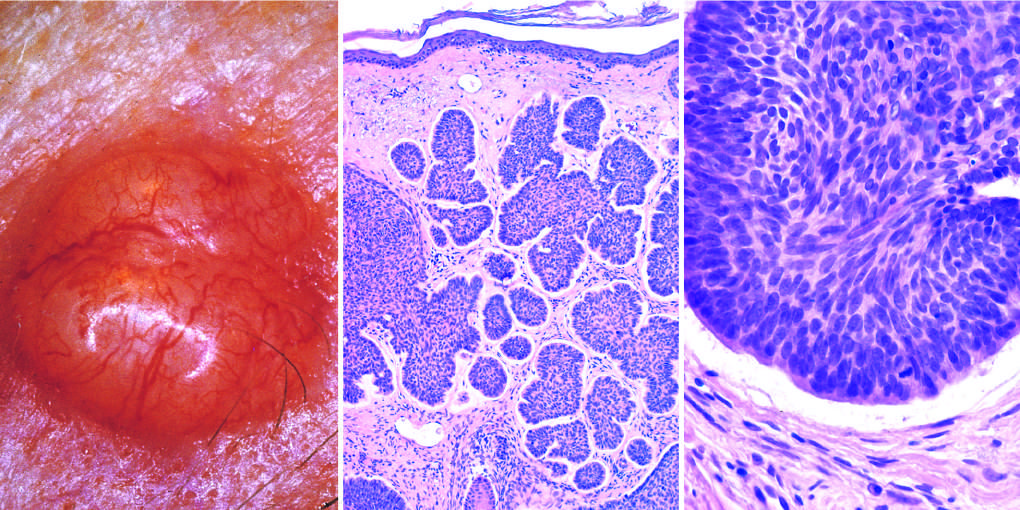what is tumor composed of?
Answer the question using a single word or phrase. Nests of basaloid cells 